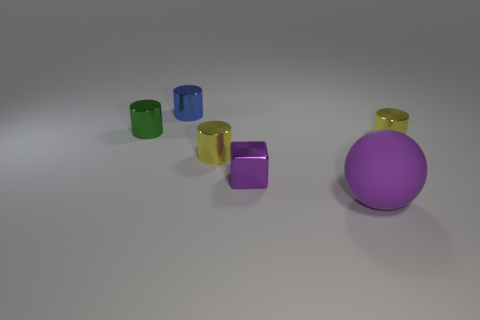Subtract 2 cylinders. How many cylinders are left? 2 Subtract all small green shiny cylinders. How many cylinders are left? 3 Add 2 blue cylinders. How many objects exist? 8 Subtract all blue cylinders. How many cylinders are left? 3 Subtract all yellow blocks. How many blue cylinders are left? 1 Subtract all large purple spheres. Subtract all purple matte spheres. How many objects are left? 4 Add 2 big purple things. How many big purple things are left? 3 Add 3 large green spheres. How many large green spheres exist? 3 Subtract 0 brown cubes. How many objects are left? 6 Subtract all blocks. How many objects are left? 5 